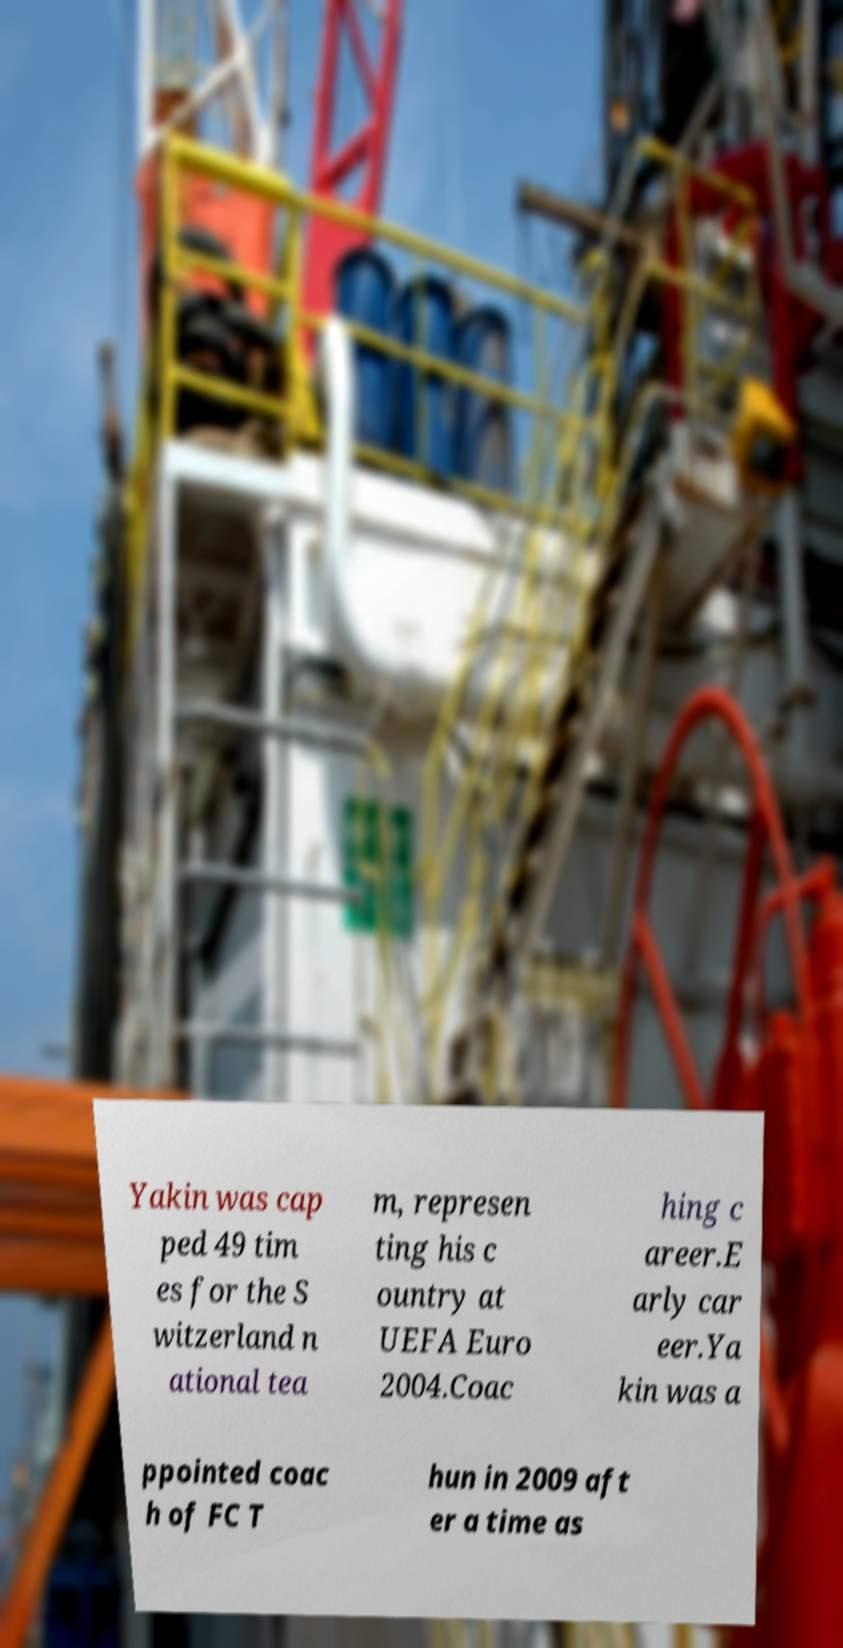Can you accurately transcribe the text from the provided image for me? Yakin was cap ped 49 tim es for the S witzerland n ational tea m, represen ting his c ountry at UEFA Euro 2004.Coac hing c areer.E arly car eer.Ya kin was a ppointed coac h of FC T hun in 2009 aft er a time as 